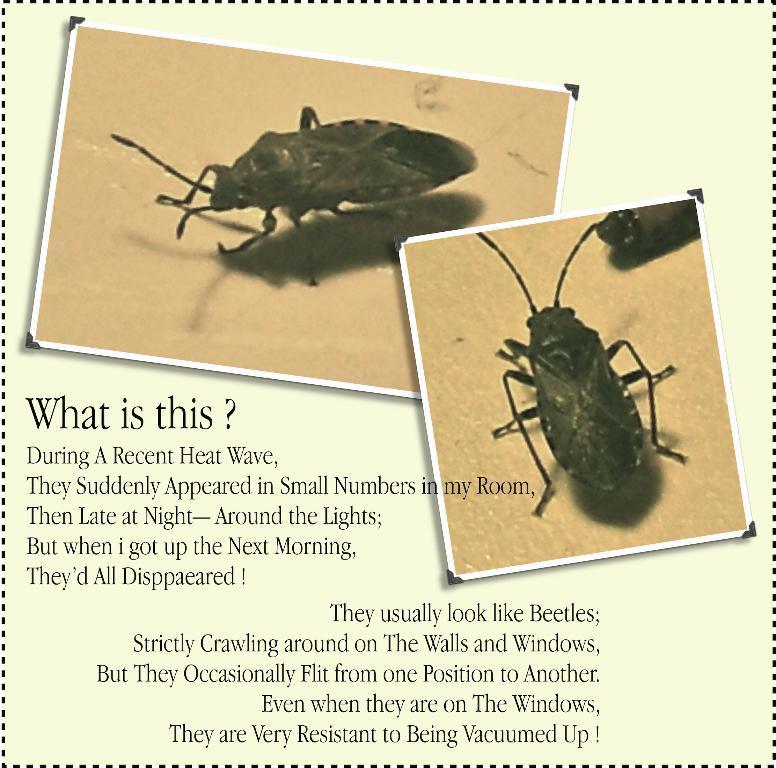Please provide a concise description of this image. In this image there is a poster in which I can see there is some text and pictures of insects. 